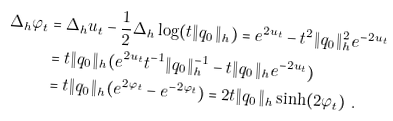Convert formula to latex. <formula><loc_0><loc_0><loc_500><loc_500>\Delta _ { h } \varphi _ { t } & = \Delta _ { h } u _ { t } - \frac { 1 } { 2 } \Delta _ { h } \log ( t \| q _ { 0 } \| _ { h } ) = e ^ { 2 u _ { t } } - t ^ { 2 } \| q _ { 0 } \| _ { h } ^ { 2 } e ^ { - 2 u _ { t } } \\ & = t \| q _ { 0 } \| _ { h } ( e ^ { 2 u _ { t } } t ^ { - 1 } \| q _ { 0 } \| _ { h } ^ { - 1 } - t \| q _ { 0 } \| _ { h } e ^ { - 2 u _ { t } } ) \\ & = t \| q _ { 0 } \| _ { h } ( e ^ { 2 \varphi _ { t } } - e ^ { - 2 \varphi _ { t } } ) = 2 t \| q _ { 0 } \| _ { h } \sinh ( 2 \varphi _ { t } ) \ .</formula> 